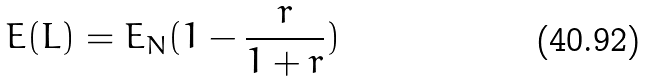<formula> <loc_0><loc_0><loc_500><loc_500>E ( L ) = E _ { N } ( 1 - \frac { r } { 1 + r } )</formula> 